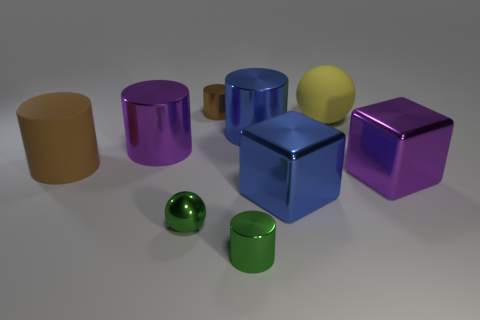The brown object that is the same size as the green shiny cylinder is what shape?
Give a very brief answer. Cylinder. Is there another small brown shiny thing of the same shape as the tiny brown thing?
Give a very brief answer. No. Is the material of the purple block the same as the blue thing that is behind the blue cube?
Keep it short and to the point. Yes. Is there a large rubber cylinder that has the same color as the big ball?
Keep it short and to the point. No. What number of other objects are the same material as the large blue cube?
Your response must be concise. 6. There is a shiny sphere; does it have the same color as the tiny metallic cylinder in front of the big purple metallic cube?
Provide a short and direct response. Yes. Are there more tiny shiny cylinders behind the brown matte object than red objects?
Offer a very short reply. Yes. How many balls are to the right of the green ball that is on the left side of the ball that is behind the green sphere?
Your answer should be very brief. 1. There is a thing that is on the left side of the big purple cylinder; is it the same shape as the brown metal thing?
Offer a terse response. Yes. There is a blue thing in front of the purple metal cylinder; what material is it?
Provide a succinct answer. Metal. 